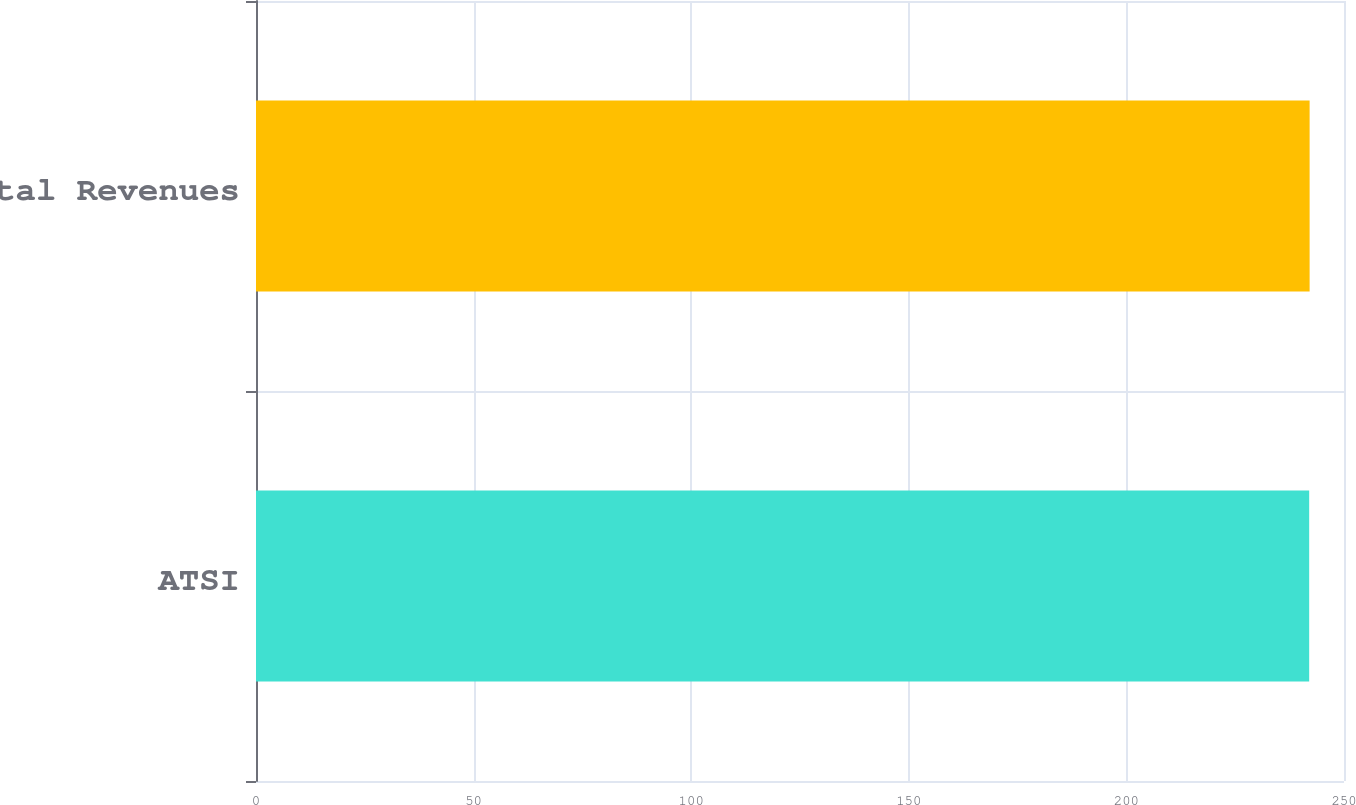Convert chart. <chart><loc_0><loc_0><loc_500><loc_500><bar_chart><fcel>ATSI<fcel>Total Revenues<nl><fcel>242<fcel>242.1<nl></chart> 